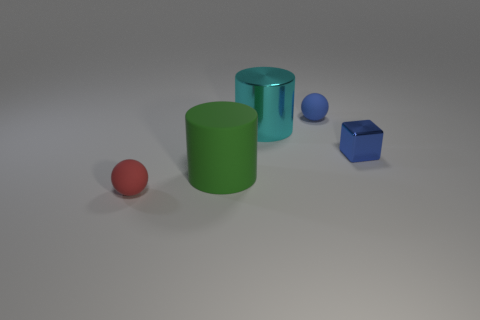There is a thing that is on the left side of the tiny blue ball and behind the big green rubber cylinder; how big is it?
Provide a succinct answer. Large. Are there more small matte spheres than blue matte objects?
Your answer should be very brief. Yes. There is a rubber thing that is to the right of the big green matte cylinder; is its shape the same as the red thing?
Provide a succinct answer. Yes. What number of matte things are either large cylinders or blue spheres?
Give a very brief answer. 2. Are there any tiny things that have the same material as the red sphere?
Keep it short and to the point. Yes. What is the material of the tiny blue cube?
Your answer should be compact. Metal. The blue object in front of the object that is behind the cylinder that is on the right side of the green rubber cylinder is what shape?
Your answer should be compact. Cube. Is the number of metallic blocks that are in front of the large cyan shiny cylinder greater than the number of things?
Your response must be concise. No. There is a big green rubber object; is it the same shape as the metallic object left of the blue matte thing?
Your answer should be very brief. Yes. What number of red rubber spheres are in front of the small blue block that is on the right side of the tiny object left of the large green rubber object?
Provide a short and direct response. 1. 